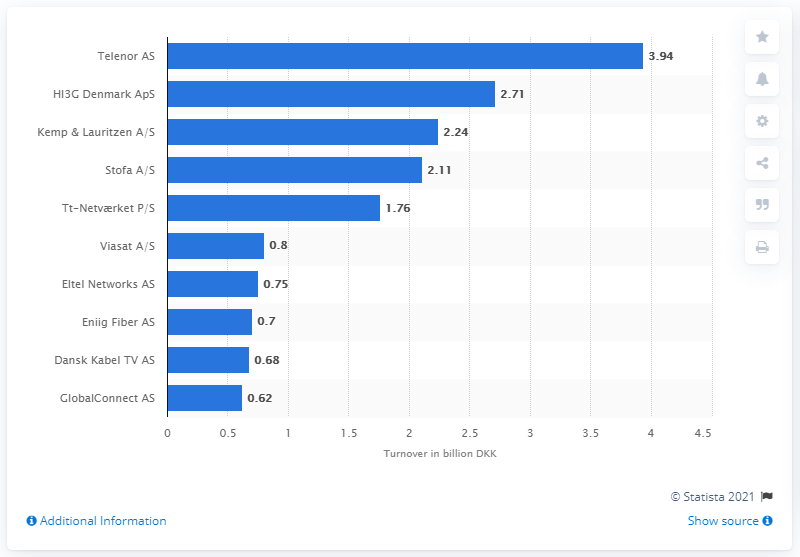Highlight a few significant elements in this photo. The turnover of HI3G Denmark ApS was 2.71... Telenor AS had the highest turnover among the leading telecom companies in Denmark in 2020. 